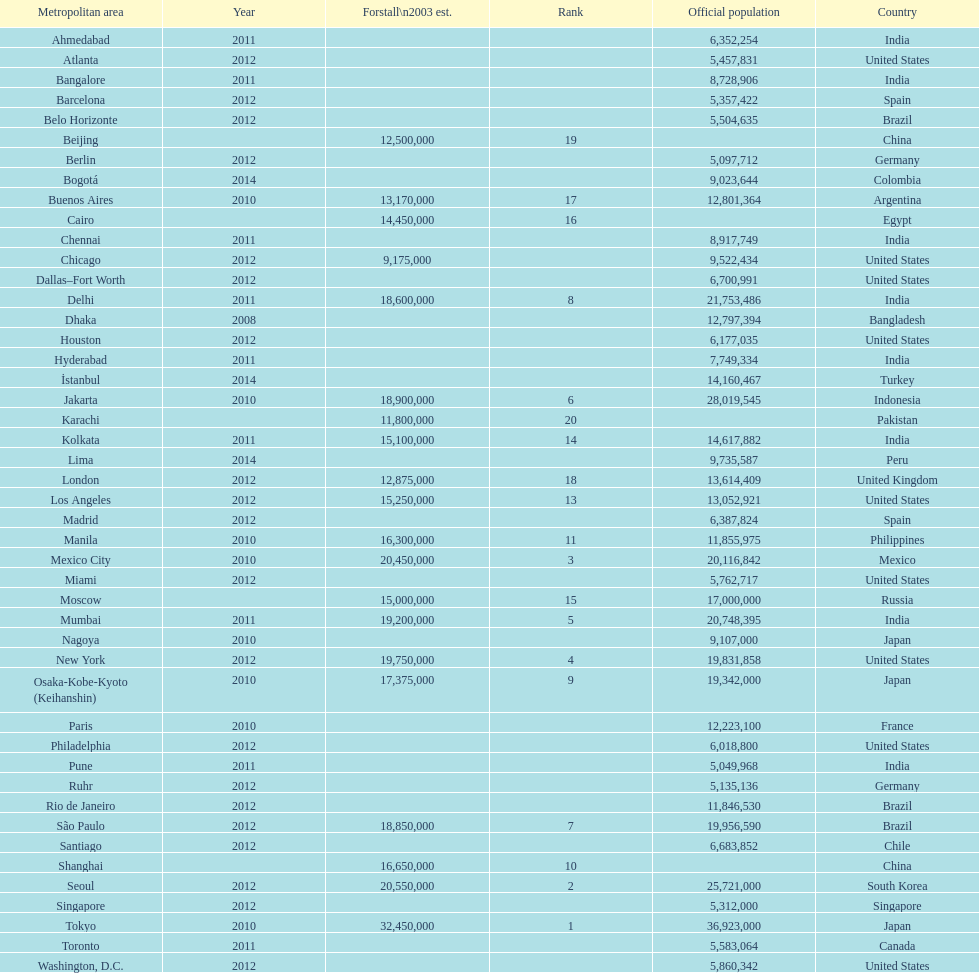What city was ranked first in 2003? Tokyo. 